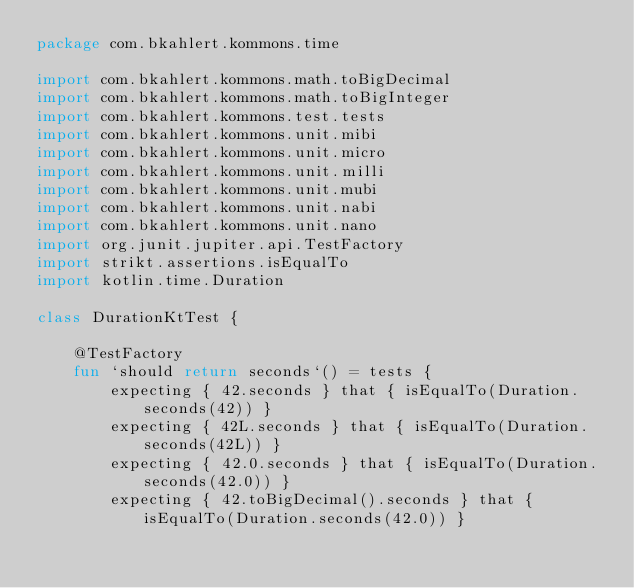<code> <loc_0><loc_0><loc_500><loc_500><_Kotlin_>package com.bkahlert.kommons.time

import com.bkahlert.kommons.math.toBigDecimal
import com.bkahlert.kommons.math.toBigInteger
import com.bkahlert.kommons.test.tests
import com.bkahlert.kommons.unit.mibi
import com.bkahlert.kommons.unit.micro
import com.bkahlert.kommons.unit.milli
import com.bkahlert.kommons.unit.mubi
import com.bkahlert.kommons.unit.nabi
import com.bkahlert.kommons.unit.nano
import org.junit.jupiter.api.TestFactory
import strikt.assertions.isEqualTo
import kotlin.time.Duration

class DurationKtTest {

    @TestFactory
    fun `should return seconds`() = tests {
        expecting { 42.seconds } that { isEqualTo(Duration.seconds(42)) }
        expecting { 42L.seconds } that { isEqualTo(Duration.seconds(42L)) }
        expecting { 42.0.seconds } that { isEqualTo(Duration.seconds(42.0)) }
        expecting { 42.toBigDecimal().seconds } that { isEqualTo(Duration.seconds(42.0)) }</code> 